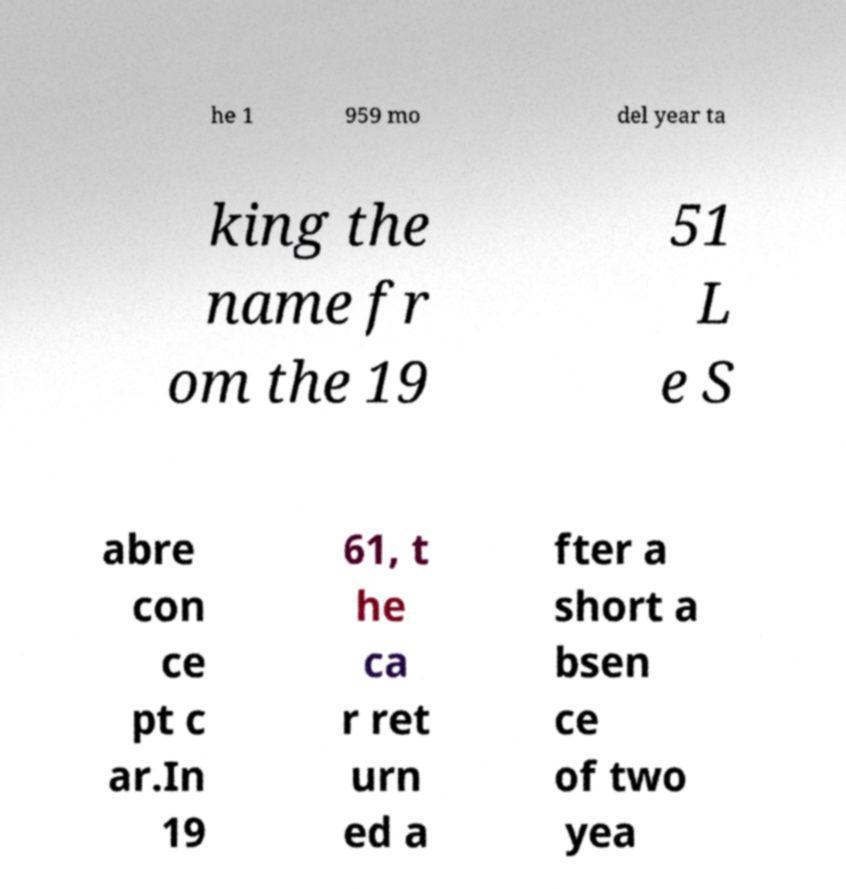Please read and relay the text visible in this image. What does it say? he 1 959 mo del year ta king the name fr om the 19 51 L e S abre con ce pt c ar.In 19 61, t he ca r ret urn ed a fter a short a bsen ce of two yea 